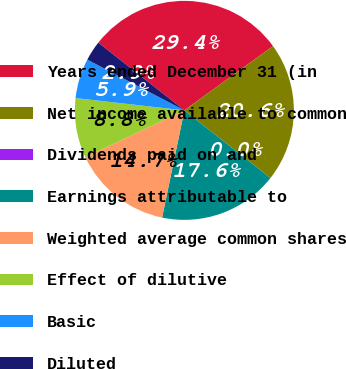Convert chart. <chart><loc_0><loc_0><loc_500><loc_500><pie_chart><fcel>Years ended December 31 (in<fcel>Net income available to common<fcel>Dividends paid on and<fcel>Earnings attributable to<fcel>Weighted average common shares<fcel>Effect of dilutive<fcel>Basic<fcel>Diluted<nl><fcel>29.41%<fcel>20.59%<fcel>0.0%<fcel>17.65%<fcel>14.71%<fcel>8.82%<fcel>5.88%<fcel>2.94%<nl></chart> 